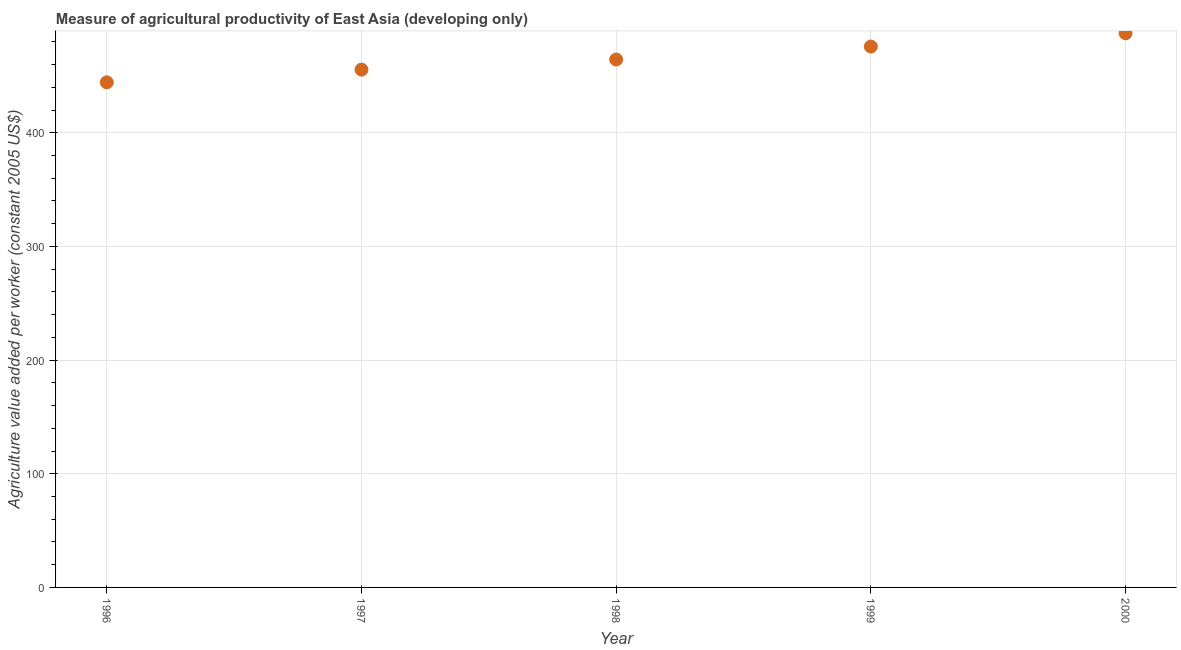What is the agriculture value added per worker in 1999?
Your answer should be compact. 475.87. Across all years, what is the maximum agriculture value added per worker?
Provide a short and direct response. 487.54. Across all years, what is the minimum agriculture value added per worker?
Your answer should be very brief. 444.38. What is the sum of the agriculture value added per worker?
Ensure brevity in your answer.  2327.81. What is the difference between the agriculture value added per worker in 1998 and 2000?
Ensure brevity in your answer.  -23.09. What is the average agriculture value added per worker per year?
Your response must be concise. 465.56. What is the median agriculture value added per worker?
Your answer should be compact. 464.46. In how many years, is the agriculture value added per worker greater than 260 US$?
Provide a short and direct response. 5. What is the ratio of the agriculture value added per worker in 1997 to that in 2000?
Your answer should be compact. 0.93. Is the difference between the agriculture value added per worker in 1996 and 1999 greater than the difference between any two years?
Your answer should be compact. No. What is the difference between the highest and the second highest agriculture value added per worker?
Provide a short and direct response. 11.68. What is the difference between the highest and the lowest agriculture value added per worker?
Ensure brevity in your answer.  43.16. In how many years, is the agriculture value added per worker greater than the average agriculture value added per worker taken over all years?
Keep it short and to the point. 2. Does the agriculture value added per worker monotonically increase over the years?
Your answer should be compact. Yes. How many years are there in the graph?
Offer a very short reply. 5. What is the difference between two consecutive major ticks on the Y-axis?
Keep it short and to the point. 100. Does the graph contain any zero values?
Make the answer very short. No. Does the graph contain grids?
Provide a short and direct response. Yes. What is the title of the graph?
Ensure brevity in your answer.  Measure of agricultural productivity of East Asia (developing only). What is the label or title of the Y-axis?
Your answer should be very brief. Agriculture value added per worker (constant 2005 US$). What is the Agriculture value added per worker (constant 2005 US$) in 1996?
Offer a terse response. 444.38. What is the Agriculture value added per worker (constant 2005 US$) in 1997?
Provide a short and direct response. 455.56. What is the Agriculture value added per worker (constant 2005 US$) in 1998?
Make the answer very short. 464.46. What is the Agriculture value added per worker (constant 2005 US$) in 1999?
Your answer should be very brief. 475.87. What is the Agriculture value added per worker (constant 2005 US$) in 2000?
Your response must be concise. 487.54. What is the difference between the Agriculture value added per worker (constant 2005 US$) in 1996 and 1997?
Keep it short and to the point. -11.18. What is the difference between the Agriculture value added per worker (constant 2005 US$) in 1996 and 1998?
Your answer should be compact. -20.07. What is the difference between the Agriculture value added per worker (constant 2005 US$) in 1996 and 1999?
Provide a short and direct response. -31.48. What is the difference between the Agriculture value added per worker (constant 2005 US$) in 1996 and 2000?
Your answer should be very brief. -43.16. What is the difference between the Agriculture value added per worker (constant 2005 US$) in 1997 and 1998?
Your answer should be very brief. -8.89. What is the difference between the Agriculture value added per worker (constant 2005 US$) in 1997 and 1999?
Your answer should be very brief. -20.3. What is the difference between the Agriculture value added per worker (constant 2005 US$) in 1997 and 2000?
Give a very brief answer. -31.98. What is the difference between the Agriculture value added per worker (constant 2005 US$) in 1998 and 1999?
Your response must be concise. -11.41. What is the difference between the Agriculture value added per worker (constant 2005 US$) in 1998 and 2000?
Provide a short and direct response. -23.09. What is the difference between the Agriculture value added per worker (constant 2005 US$) in 1999 and 2000?
Offer a terse response. -11.68. What is the ratio of the Agriculture value added per worker (constant 2005 US$) in 1996 to that in 1998?
Provide a succinct answer. 0.96. What is the ratio of the Agriculture value added per worker (constant 2005 US$) in 1996 to that in 1999?
Your answer should be very brief. 0.93. What is the ratio of the Agriculture value added per worker (constant 2005 US$) in 1996 to that in 2000?
Your answer should be compact. 0.91. What is the ratio of the Agriculture value added per worker (constant 2005 US$) in 1997 to that in 1999?
Give a very brief answer. 0.96. What is the ratio of the Agriculture value added per worker (constant 2005 US$) in 1997 to that in 2000?
Offer a very short reply. 0.93. What is the ratio of the Agriculture value added per worker (constant 2005 US$) in 1998 to that in 1999?
Make the answer very short. 0.98. What is the ratio of the Agriculture value added per worker (constant 2005 US$) in 1998 to that in 2000?
Your answer should be very brief. 0.95. What is the ratio of the Agriculture value added per worker (constant 2005 US$) in 1999 to that in 2000?
Keep it short and to the point. 0.98. 